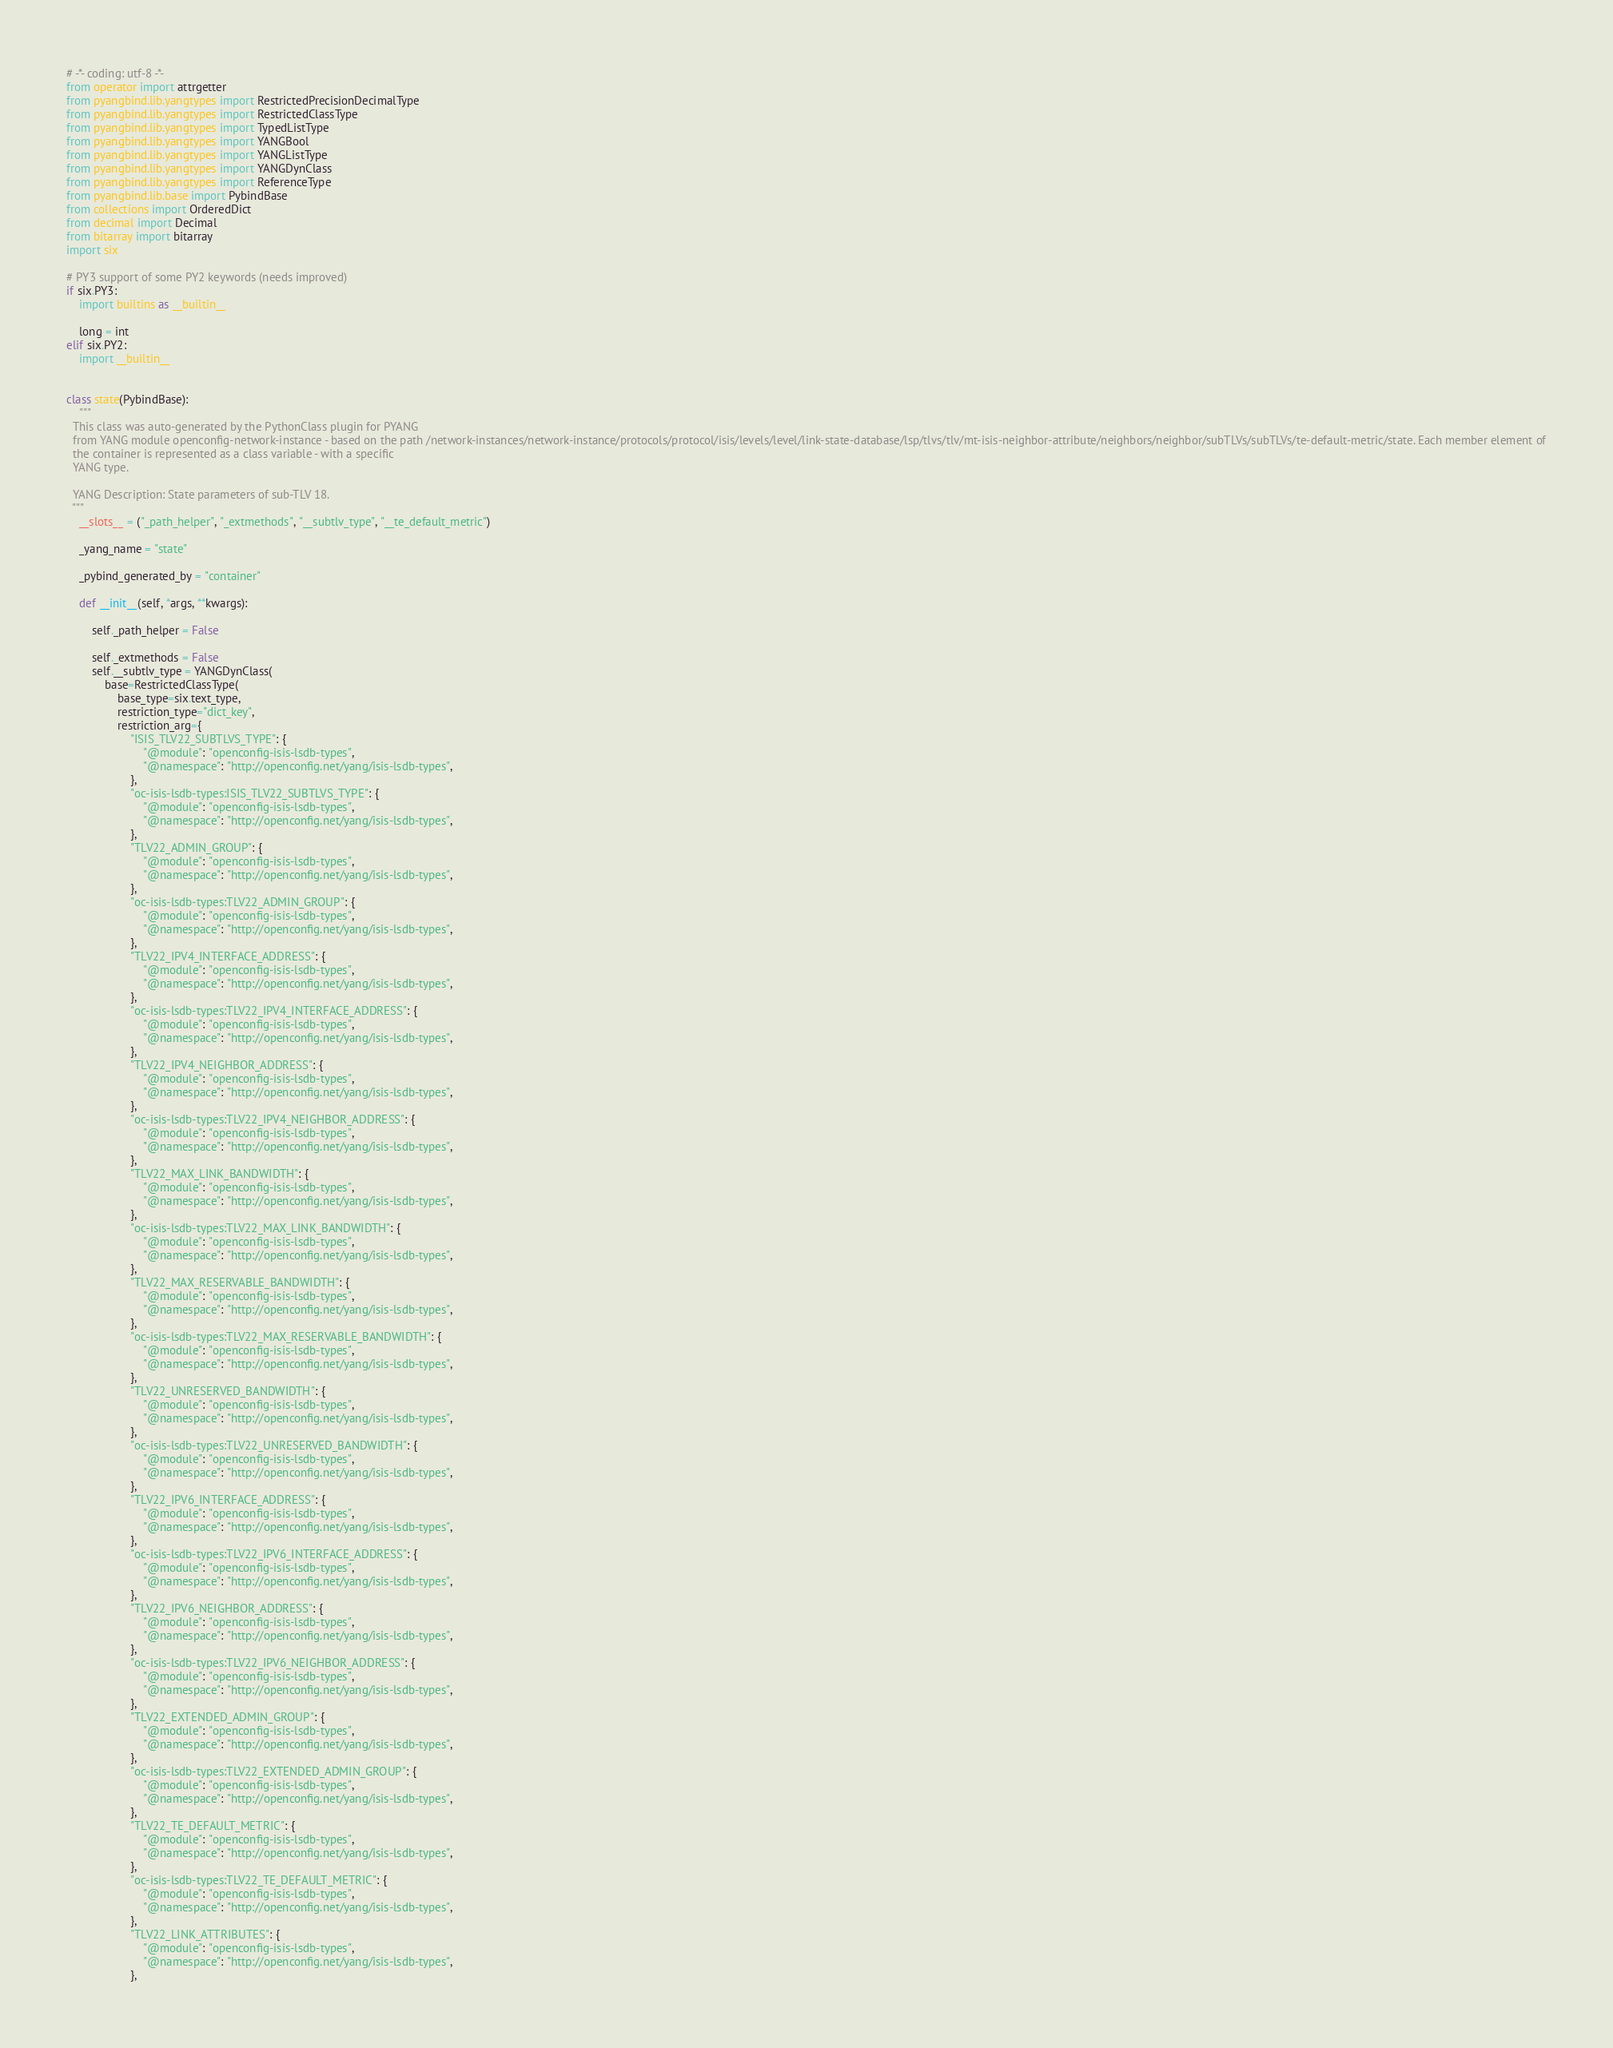<code> <loc_0><loc_0><loc_500><loc_500><_Python_># -*- coding: utf-8 -*-
from operator import attrgetter
from pyangbind.lib.yangtypes import RestrictedPrecisionDecimalType
from pyangbind.lib.yangtypes import RestrictedClassType
from pyangbind.lib.yangtypes import TypedListType
from pyangbind.lib.yangtypes import YANGBool
from pyangbind.lib.yangtypes import YANGListType
from pyangbind.lib.yangtypes import YANGDynClass
from pyangbind.lib.yangtypes import ReferenceType
from pyangbind.lib.base import PybindBase
from collections import OrderedDict
from decimal import Decimal
from bitarray import bitarray
import six

# PY3 support of some PY2 keywords (needs improved)
if six.PY3:
    import builtins as __builtin__

    long = int
elif six.PY2:
    import __builtin__


class state(PybindBase):
    """
  This class was auto-generated by the PythonClass plugin for PYANG
  from YANG module openconfig-network-instance - based on the path /network-instances/network-instance/protocols/protocol/isis/levels/level/link-state-database/lsp/tlvs/tlv/mt-isis-neighbor-attribute/neighbors/neighbor/subTLVs/subTLVs/te-default-metric/state. Each member element of
  the container is represented as a class variable - with a specific
  YANG type.

  YANG Description: State parameters of sub-TLV 18.
  """
    __slots__ = ("_path_helper", "_extmethods", "__subtlv_type", "__te_default_metric")

    _yang_name = "state"

    _pybind_generated_by = "container"

    def __init__(self, *args, **kwargs):

        self._path_helper = False

        self._extmethods = False
        self.__subtlv_type = YANGDynClass(
            base=RestrictedClassType(
                base_type=six.text_type,
                restriction_type="dict_key",
                restriction_arg={
                    "ISIS_TLV22_SUBTLVS_TYPE": {
                        "@module": "openconfig-isis-lsdb-types",
                        "@namespace": "http://openconfig.net/yang/isis-lsdb-types",
                    },
                    "oc-isis-lsdb-types:ISIS_TLV22_SUBTLVS_TYPE": {
                        "@module": "openconfig-isis-lsdb-types",
                        "@namespace": "http://openconfig.net/yang/isis-lsdb-types",
                    },
                    "TLV22_ADMIN_GROUP": {
                        "@module": "openconfig-isis-lsdb-types",
                        "@namespace": "http://openconfig.net/yang/isis-lsdb-types",
                    },
                    "oc-isis-lsdb-types:TLV22_ADMIN_GROUP": {
                        "@module": "openconfig-isis-lsdb-types",
                        "@namespace": "http://openconfig.net/yang/isis-lsdb-types",
                    },
                    "TLV22_IPV4_INTERFACE_ADDRESS": {
                        "@module": "openconfig-isis-lsdb-types",
                        "@namespace": "http://openconfig.net/yang/isis-lsdb-types",
                    },
                    "oc-isis-lsdb-types:TLV22_IPV4_INTERFACE_ADDRESS": {
                        "@module": "openconfig-isis-lsdb-types",
                        "@namespace": "http://openconfig.net/yang/isis-lsdb-types",
                    },
                    "TLV22_IPV4_NEIGHBOR_ADDRESS": {
                        "@module": "openconfig-isis-lsdb-types",
                        "@namespace": "http://openconfig.net/yang/isis-lsdb-types",
                    },
                    "oc-isis-lsdb-types:TLV22_IPV4_NEIGHBOR_ADDRESS": {
                        "@module": "openconfig-isis-lsdb-types",
                        "@namespace": "http://openconfig.net/yang/isis-lsdb-types",
                    },
                    "TLV22_MAX_LINK_BANDWIDTH": {
                        "@module": "openconfig-isis-lsdb-types",
                        "@namespace": "http://openconfig.net/yang/isis-lsdb-types",
                    },
                    "oc-isis-lsdb-types:TLV22_MAX_LINK_BANDWIDTH": {
                        "@module": "openconfig-isis-lsdb-types",
                        "@namespace": "http://openconfig.net/yang/isis-lsdb-types",
                    },
                    "TLV22_MAX_RESERVABLE_BANDWIDTH": {
                        "@module": "openconfig-isis-lsdb-types",
                        "@namespace": "http://openconfig.net/yang/isis-lsdb-types",
                    },
                    "oc-isis-lsdb-types:TLV22_MAX_RESERVABLE_BANDWIDTH": {
                        "@module": "openconfig-isis-lsdb-types",
                        "@namespace": "http://openconfig.net/yang/isis-lsdb-types",
                    },
                    "TLV22_UNRESERVED_BANDWIDTH": {
                        "@module": "openconfig-isis-lsdb-types",
                        "@namespace": "http://openconfig.net/yang/isis-lsdb-types",
                    },
                    "oc-isis-lsdb-types:TLV22_UNRESERVED_BANDWIDTH": {
                        "@module": "openconfig-isis-lsdb-types",
                        "@namespace": "http://openconfig.net/yang/isis-lsdb-types",
                    },
                    "TLV22_IPV6_INTERFACE_ADDRESS": {
                        "@module": "openconfig-isis-lsdb-types",
                        "@namespace": "http://openconfig.net/yang/isis-lsdb-types",
                    },
                    "oc-isis-lsdb-types:TLV22_IPV6_INTERFACE_ADDRESS": {
                        "@module": "openconfig-isis-lsdb-types",
                        "@namespace": "http://openconfig.net/yang/isis-lsdb-types",
                    },
                    "TLV22_IPV6_NEIGHBOR_ADDRESS": {
                        "@module": "openconfig-isis-lsdb-types",
                        "@namespace": "http://openconfig.net/yang/isis-lsdb-types",
                    },
                    "oc-isis-lsdb-types:TLV22_IPV6_NEIGHBOR_ADDRESS": {
                        "@module": "openconfig-isis-lsdb-types",
                        "@namespace": "http://openconfig.net/yang/isis-lsdb-types",
                    },
                    "TLV22_EXTENDED_ADMIN_GROUP": {
                        "@module": "openconfig-isis-lsdb-types",
                        "@namespace": "http://openconfig.net/yang/isis-lsdb-types",
                    },
                    "oc-isis-lsdb-types:TLV22_EXTENDED_ADMIN_GROUP": {
                        "@module": "openconfig-isis-lsdb-types",
                        "@namespace": "http://openconfig.net/yang/isis-lsdb-types",
                    },
                    "TLV22_TE_DEFAULT_METRIC": {
                        "@module": "openconfig-isis-lsdb-types",
                        "@namespace": "http://openconfig.net/yang/isis-lsdb-types",
                    },
                    "oc-isis-lsdb-types:TLV22_TE_DEFAULT_METRIC": {
                        "@module": "openconfig-isis-lsdb-types",
                        "@namespace": "http://openconfig.net/yang/isis-lsdb-types",
                    },
                    "TLV22_LINK_ATTRIBUTES": {
                        "@module": "openconfig-isis-lsdb-types",
                        "@namespace": "http://openconfig.net/yang/isis-lsdb-types",
                    },</code> 